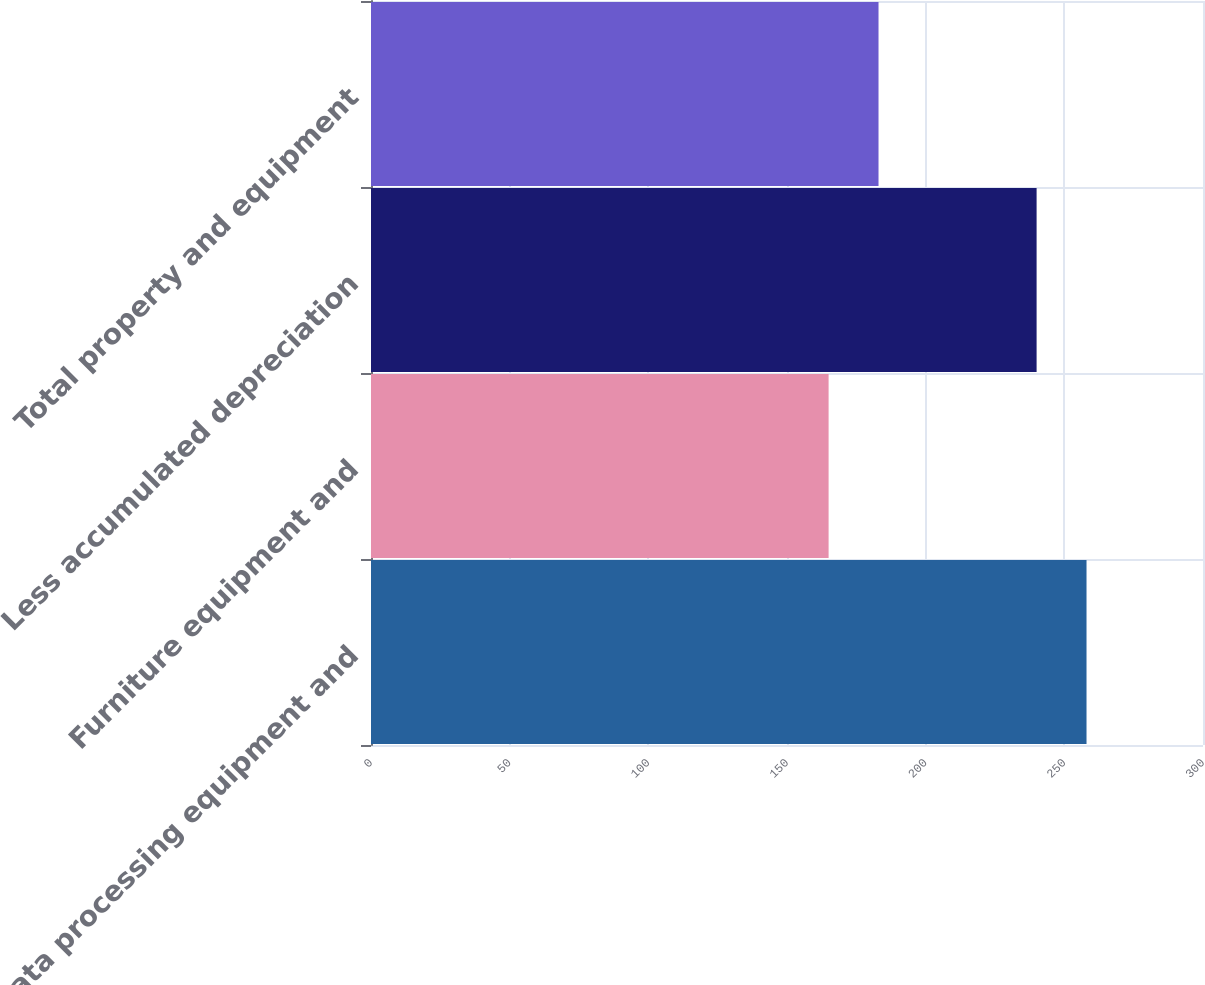<chart> <loc_0><loc_0><loc_500><loc_500><bar_chart><fcel>Data processing equipment and<fcel>Furniture equipment and<fcel>Less accumulated depreciation<fcel>Total property and equipment<nl><fcel>258<fcel>165<fcel>240<fcel>183<nl></chart> 